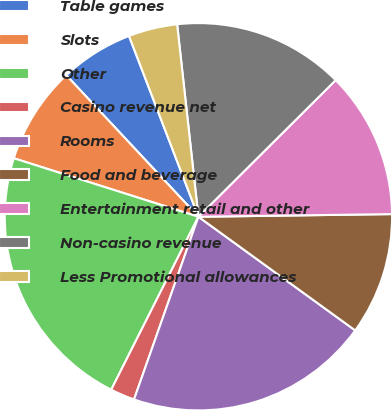Convert chart. <chart><loc_0><loc_0><loc_500><loc_500><pie_chart><fcel>Table games<fcel>Slots<fcel>Other<fcel>Casino revenue net<fcel>Rooms<fcel>Food and beverage<fcel>Entertainment retail and other<fcel>Non-casino revenue<fcel>Less Promotional allowances<nl><fcel>6.12%<fcel>8.16%<fcel>22.45%<fcel>2.04%<fcel>20.41%<fcel>10.2%<fcel>12.24%<fcel>14.29%<fcel>4.08%<nl></chart> 